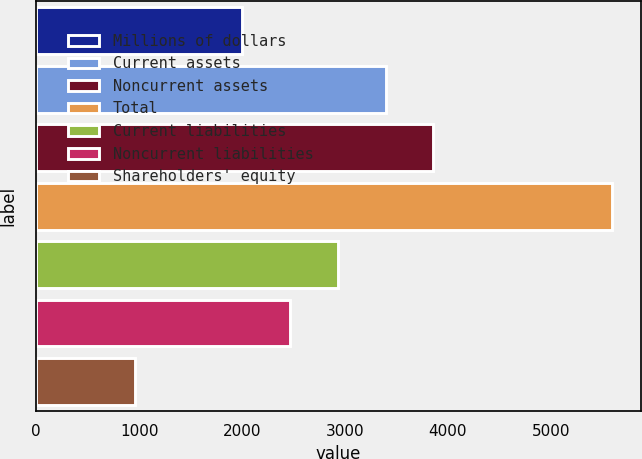<chart> <loc_0><loc_0><loc_500><loc_500><bar_chart><fcel>Millions of dollars<fcel>Current assets<fcel>Noncurrent assets<fcel>Total<fcel>Current liabilities<fcel>Noncurrent liabilities<fcel>Shareholders' equity<nl><fcel>2003<fcel>3395.3<fcel>3859.4<fcel>5596<fcel>2931.2<fcel>2467.1<fcel>955<nl></chart> 